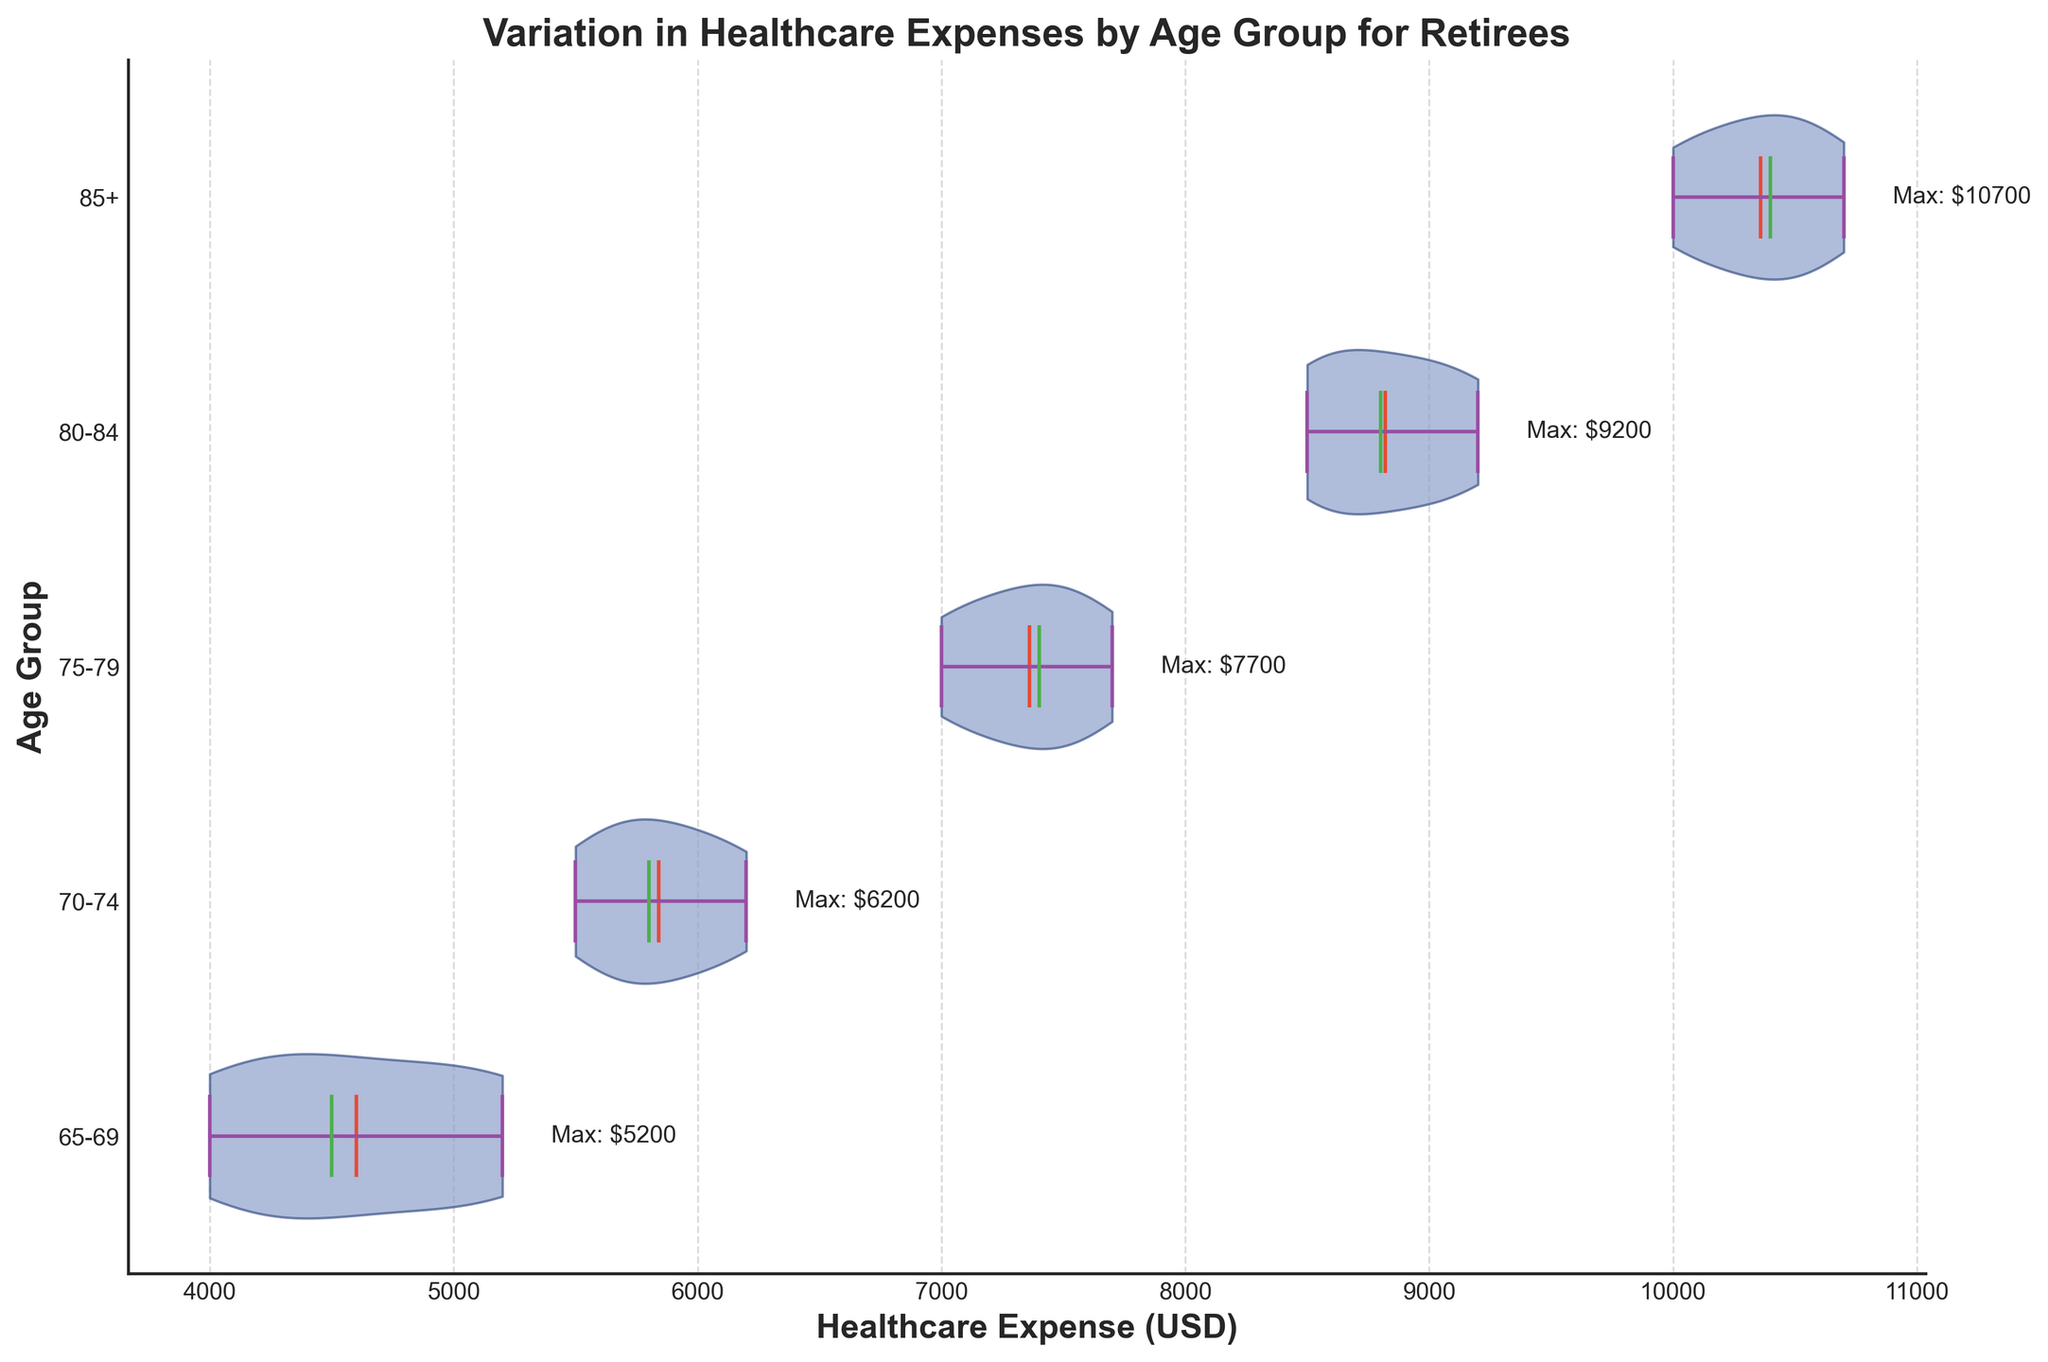What is the title of the chart? The title is displayed prominently at the top of the chart in bold text. It provides a clear and concise description of what the chart represents. You can read it directly from the figure.
Answer: Variation in Healthcare Expenses by Age Group for Retirees What is the median healthcare expense for the 70-74 age group? Look at the horizontal line inside the violin plot for the 70-74 age group, which represents the median value. This information is visually provided in each violin plot.
Answer: $5800 Which age group has the highest mean healthcare expense? Identify the age group with the highest mean value, represented by the marker (usually a dot or line) inside the plot. Compare the mean markers across all age groups.
Answer: 85+ How many age groups are represented in the chart? Count the number of distinct age groups along the y-axis. Each age group is labeled and represented by a separate violin plot.
Answer: 5 What is the minimum healthcare expense for the 80-84 age group? Look for the lowest point of the violin plot for the 80-84 age group. It is often marked with a horizontal line or another indicator at the bottom of the plot.
Answer: $8500 How do the maximum healthcare expenses compare between the 65-69 and 75-79 age groups? Identify the maximum value for both age groups by looking at the highest point in their respective violin plots. Compare these values directly.
Answer: 75-79 has a higher maximum expense than 65-69 Which age group shows the largest range in healthcare expenses? Compare the distance between the minimum and maximum values (the range) for each age group by observing the span of each violin plot from bottom to top.
Answer: 85+ What color represents the central mean line in the chart? Observe the color used for the mean line within the violin plots, which is visually distinguished from other elements. This line is colored to signify the mean healthcare expense.
Answer: Red What is the median healthcare expense for the 85+ age group? Locate the horizontal line within the violin plot for the 85+ age group, which represents the median value. This line visually indicates the central healthcare expense point.
Answer: $10400 